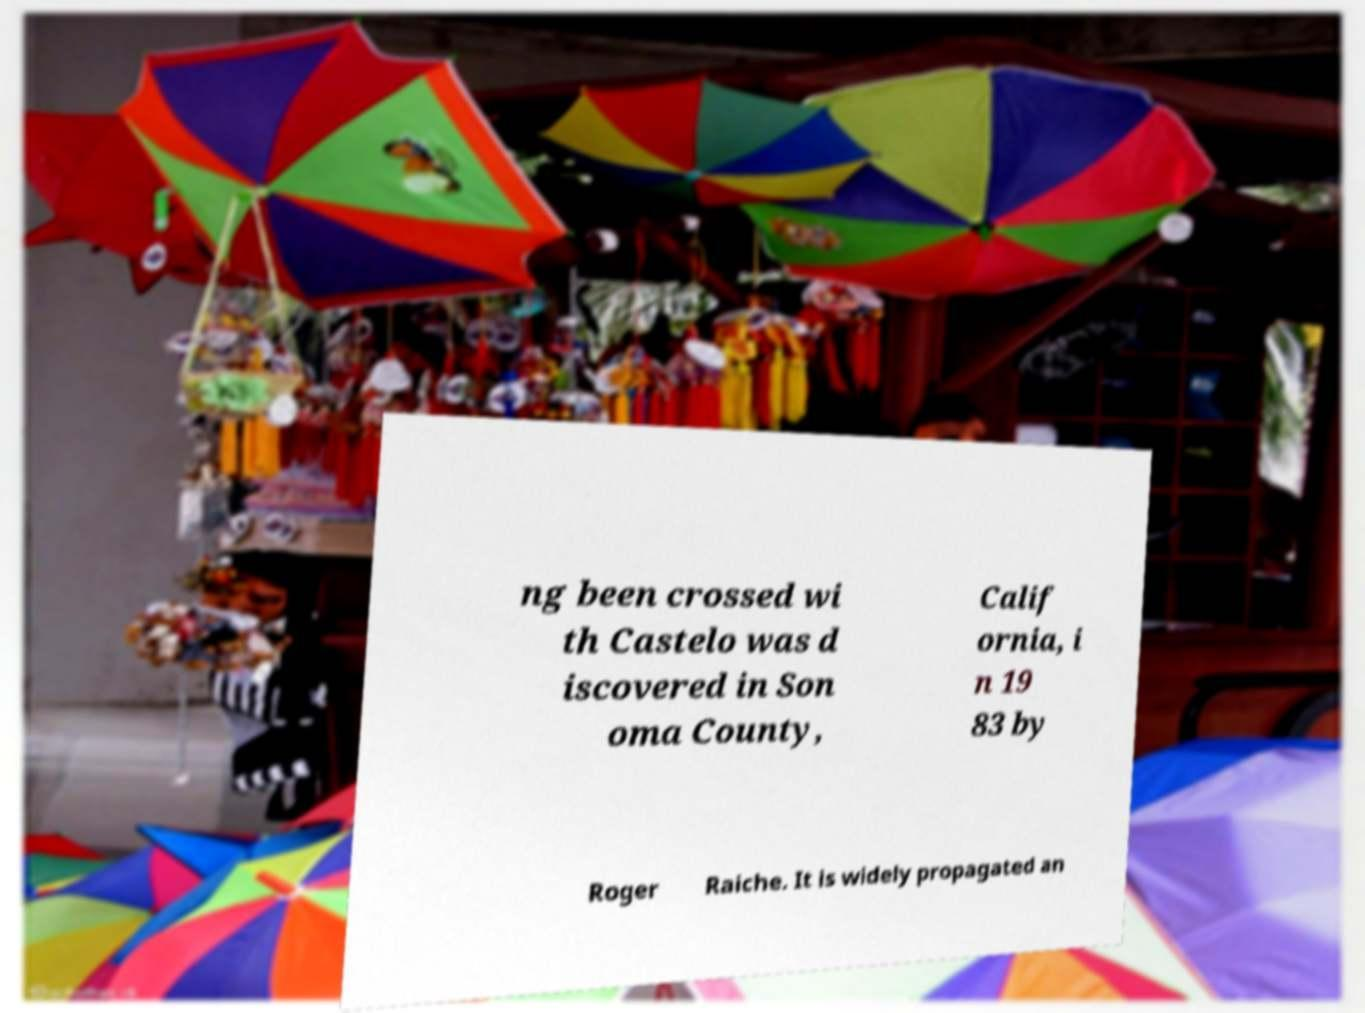Could you extract and type out the text from this image? ng been crossed wi th Castelo was d iscovered in Son oma County, Calif ornia, i n 19 83 by Roger Raiche. It is widely propagated an 